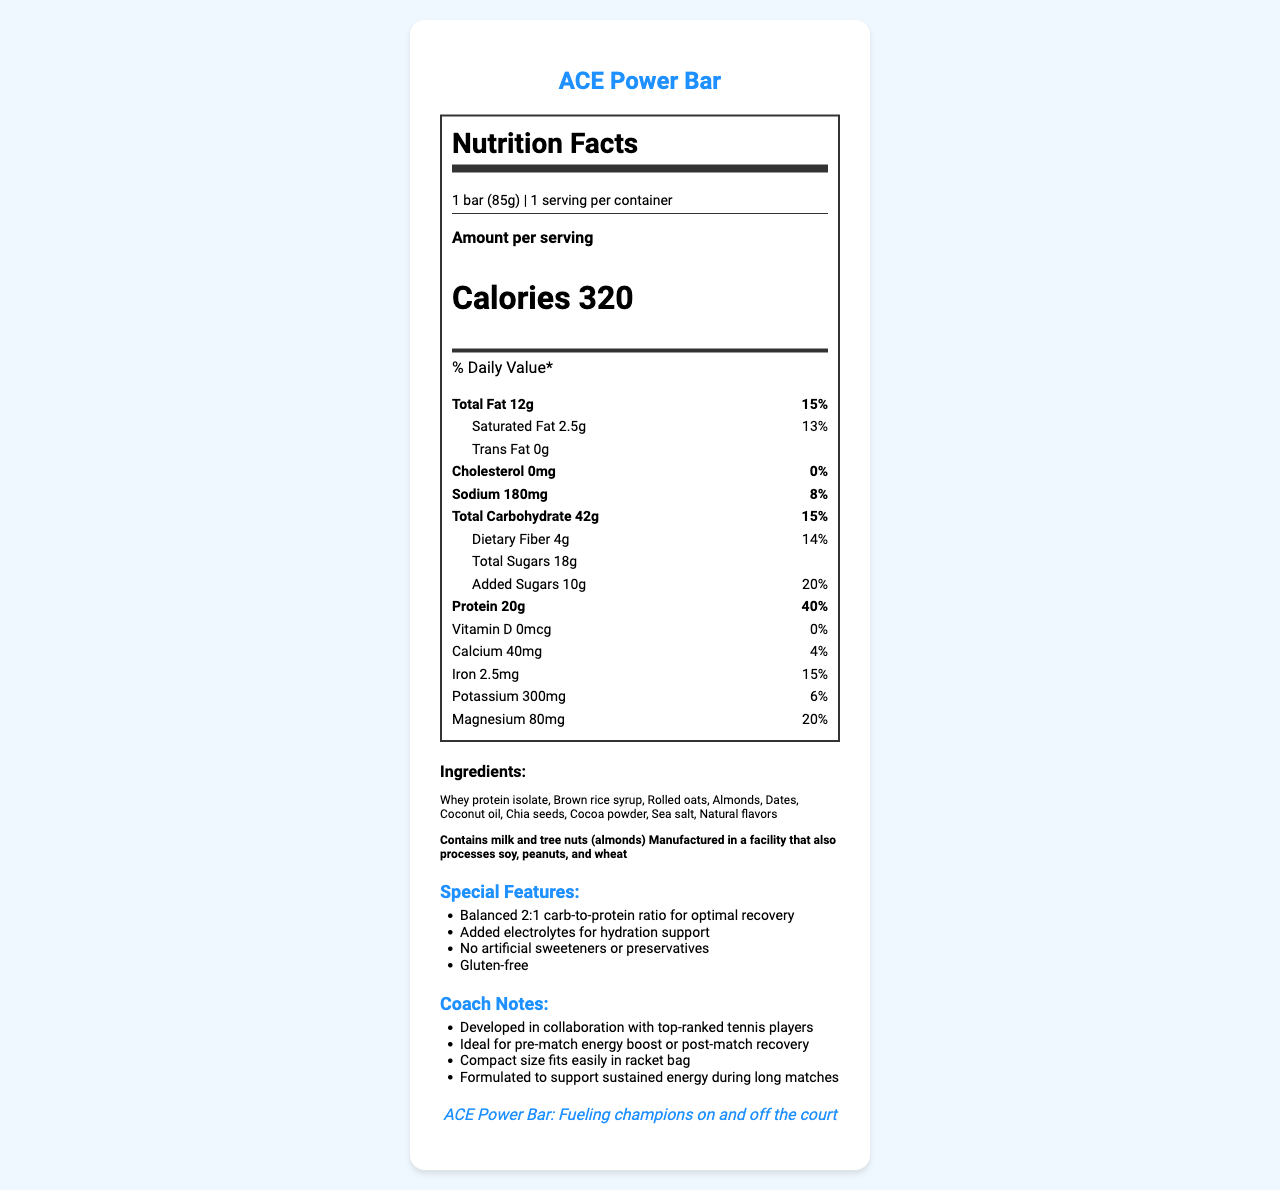What is the serving size of the ACE Power Bar? The serving size is clearly stated as "1 bar (85g)" in the nutrition facts section.
Answer: 1 bar (85g) How many calories are in one ACE Power Bar? The calories per serving are listed as 320 in the nutrition facts section.
Answer: 320 What percentage of the daily value of protein does the ACE Power Bar provide? The nutrition facts section states that the bar provides 20g of protein, which equals 40% of the daily value.
Answer: 40% What is the amount of added sugars in the ACE Power Bar? The nutrition facts section lists added sugars as 10g.
Answer: 10g Which ingredients in the ACE Power Bar contain allergens? The allergens section notes that the bar contains milk and tree nuts (almonds).
Answer: Milk and tree nuts (almonds) How much sodium does the ACE Power Bar contain? The nutritional facts list the sodium content as 180mg.
Answer: 180mg Does the ACE Power Bar contain any trans fat? The nutrition facts indicate that the bar contains 0g of trans fat.
Answer: No List one special feature of the ACE Power Bar designed for professional athletes. The special features section lists several unique points, including a balanced 2:1 carb-to-protein ratio for optimal recovery.
Answer: Balanced 2:1 carb-to-protein ratio for optimal recovery Which of the following nutrients is NOT listed in the ACE Power Bar? A. Vitamin D B. Calcium C. Vitamin C D. Magnesium Vitamin C is not listed, while Vitamin D, Calcium, and Magnesium are mentioned in the document.
Answer: C. Vitamin C Which ingredient in the ACE Power Bar is likely the primary source of fiber? A. Chia seeds B. Whey protein isolate C. Brown rice syrup D. Sea salt Chia seeds are a common source of dietary fiber, more so than the other listed ingredients.
Answer: A. Chia seeds Is the ACE Power Bar gluten-free? The special features section explicitly states that the bar is gluten-free.
Answer: Yes Summarize the main features of the ACE Power Bar. The document describes the nutritional content, ingredients, allergen information, and special features of the ACE Power Bar, emphasizing its suitability for professional athletes and its composition for optimal performance and recovery.
Answer: The ACE Power Bar is designed for high-performance tennis players, offering a balanced 2:1 carb-to-protein ratio, added electrolytes for hydration, no artificial sweeteners or preservatives, and a gluten-free formulation. It contains 320 calories, 20g of protein, and key nutrients like calcium, iron, potassium, and magnesium. The bar also includes natural ingredients such as whey protein isolate, almonds, and chia seeds, while being aware of common allergens like milk and tree nuts. How does the ACE Power Bar support hydration? The special features section states that the bar contains added electrolytes for hydration support.
Answer: Added electrolytes Can this document provide a detailed breakdown of the manufacturing process of the ACE Power Bar? The document provides nutritional information, ingredients, special features, and coach notes but does not detail the manufacturing process.
Answer: Not enough information What is the main brand statement of the ACE Power Bar? The brand statement is clearly presented at the end of the document.
Answer: ACE Power Bar: Fueling champions on and off the court 